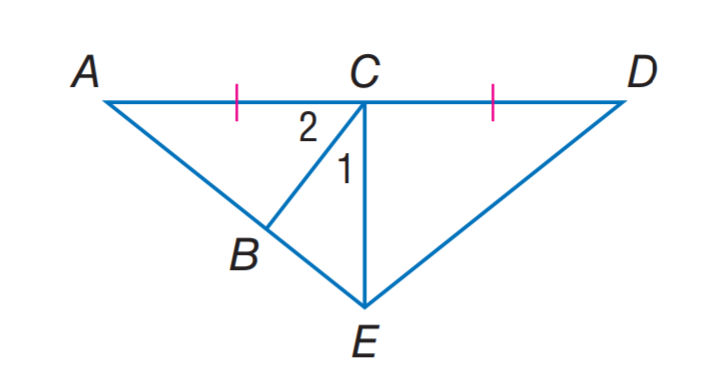Answer the mathemtical geometry problem and directly provide the correct option letter.
Question: If E C is an altitude of \triangle A E D, m \angle 1 = 2 x + 7, and m \angle 2 = 3 x + 13, find m \angle 2.
Choices: A: 25 B: 35 C: 45 D: 55 D 